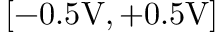Convert formula to latex. <formula><loc_0><loc_0><loc_500><loc_500>[ - 0 . 5 V , + 0 . 5 V ]</formula> 